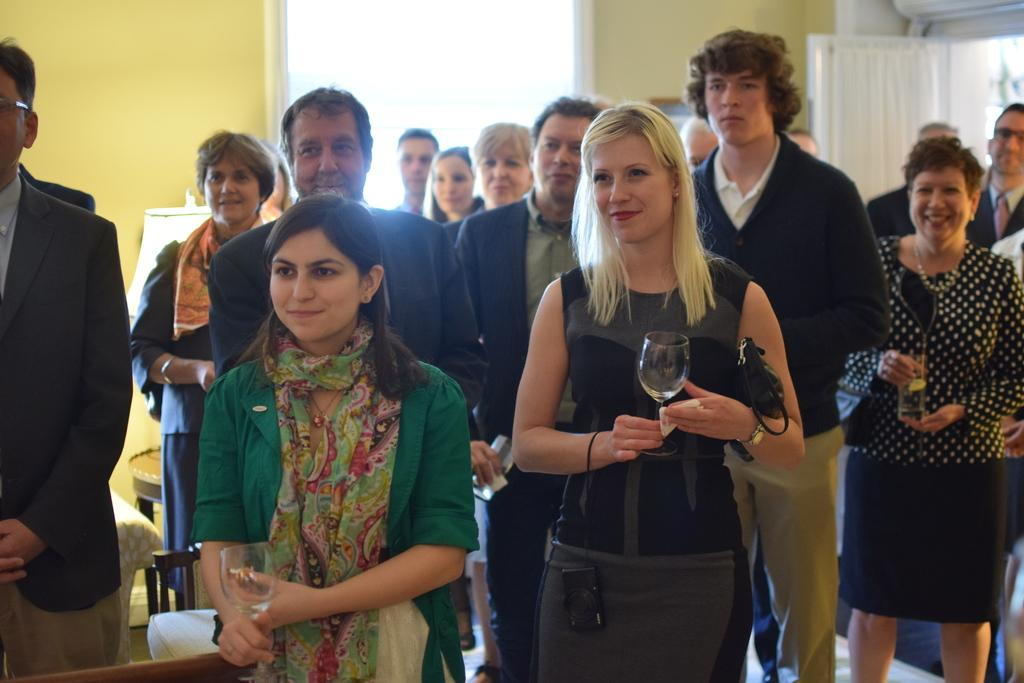What is happening in the image involving a group of people? There is a group of people in the image, and they are holding wine glasses. Where are the people located in the image? The group of people is in the middle of the image. What can be seen on the left side of the image? There is a light on the left side of the image. What type of powder is being used by the people in the image? There is no powder present in the image; the people are holding wine glasses. Where is the library located in the image? There is no library present in the image; it features a group of people holding wine glasses in the middle of the image. 